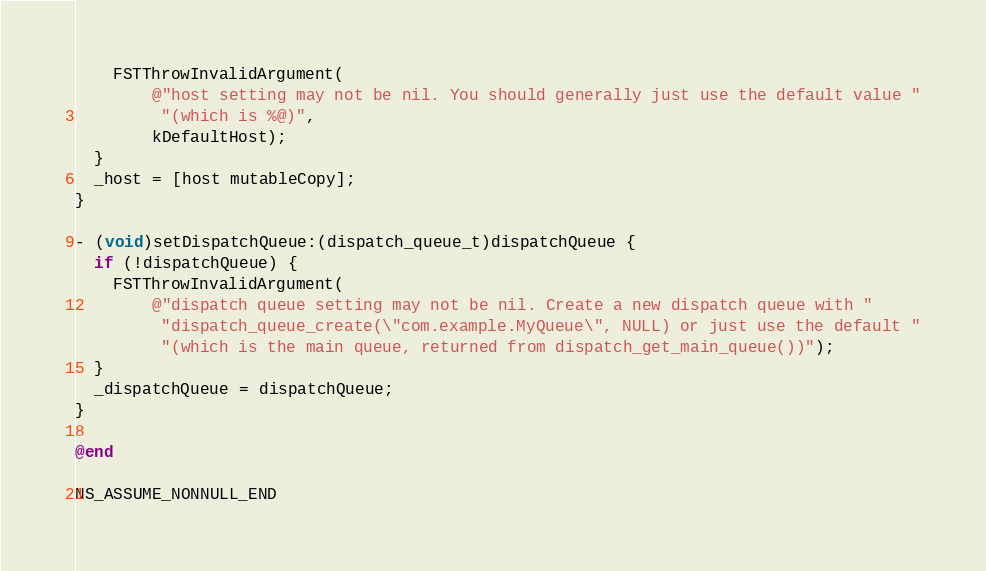<code> <loc_0><loc_0><loc_500><loc_500><_ObjectiveC_>    FSTThrowInvalidArgument(
        @"host setting may not be nil. You should generally just use the default value "
         "(which is %@)",
        kDefaultHost);
  }
  _host = [host mutableCopy];
}

- (void)setDispatchQueue:(dispatch_queue_t)dispatchQueue {
  if (!dispatchQueue) {
    FSTThrowInvalidArgument(
        @"dispatch queue setting may not be nil. Create a new dispatch queue with "
         "dispatch_queue_create(\"com.example.MyQueue\", NULL) or just use the default "
         "(which is the main queue, returned from dispatch_get_main_queue())");
  }
  _dispatchQueue = dispatchQueue;
}

@end

NS_ASSUME_NONNULL_END
</code> 